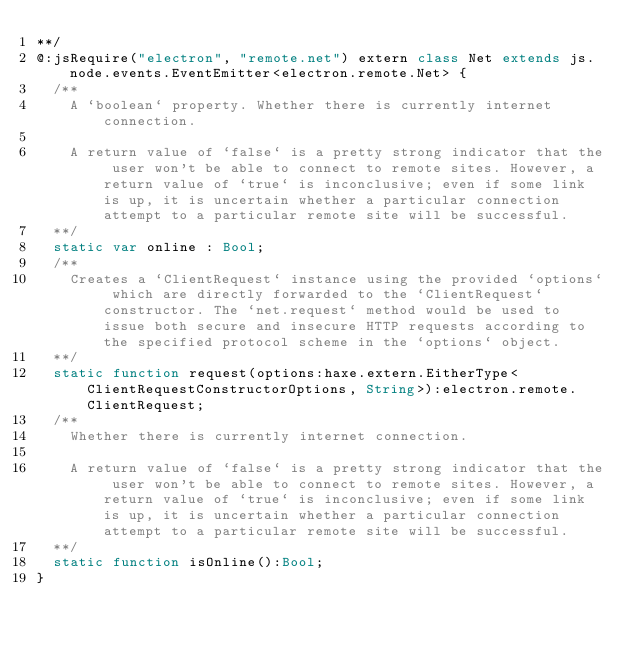Convert code to text. <code><loc_0><loc_0><loc_500><loc_500><_Haxe_>**/
@:jsRequire("electron", "remote.net") extern class Net extends js.node.events.EventEmitter<electron.remote.Net> {
	/**
		A `boolean` property. Whether there is currently internet connection.
		
		A return value of `false` is a pretty strong indicator that the user won't be able to connect to remote sites. However, a return value of `true` is inconclusive; even if some link is up, it is uncertain whether a particular connection attempt to a particular remote site will be successful.
	**/
	static var online : Bool;
	/**
		Creates a `ClientRequest` instance using the provided `options` which are directly forwarded to the `ClientRequest` constructor. The `net.request` method would be used to issue both secure and insecure HTTP requests according to the specified protocol scheme in the `options` object.
	**/
	static function request(options:haxe.extern.EitherType<ClientRequestConstructorOptions, String>):electron.remote.ClientRequest;
	/**
		Whether there is currently internet connection.
		
		A return value of `false` is a pretty strong indicator that the user won't be able to connect to remote sites. However, a return value of `true` is inconclusive; even if some link is up, it is uncertain whether a particular connection attempt to a particular remote site will be successful.
	**/
	static function isOnline():Bool;
}</code> 